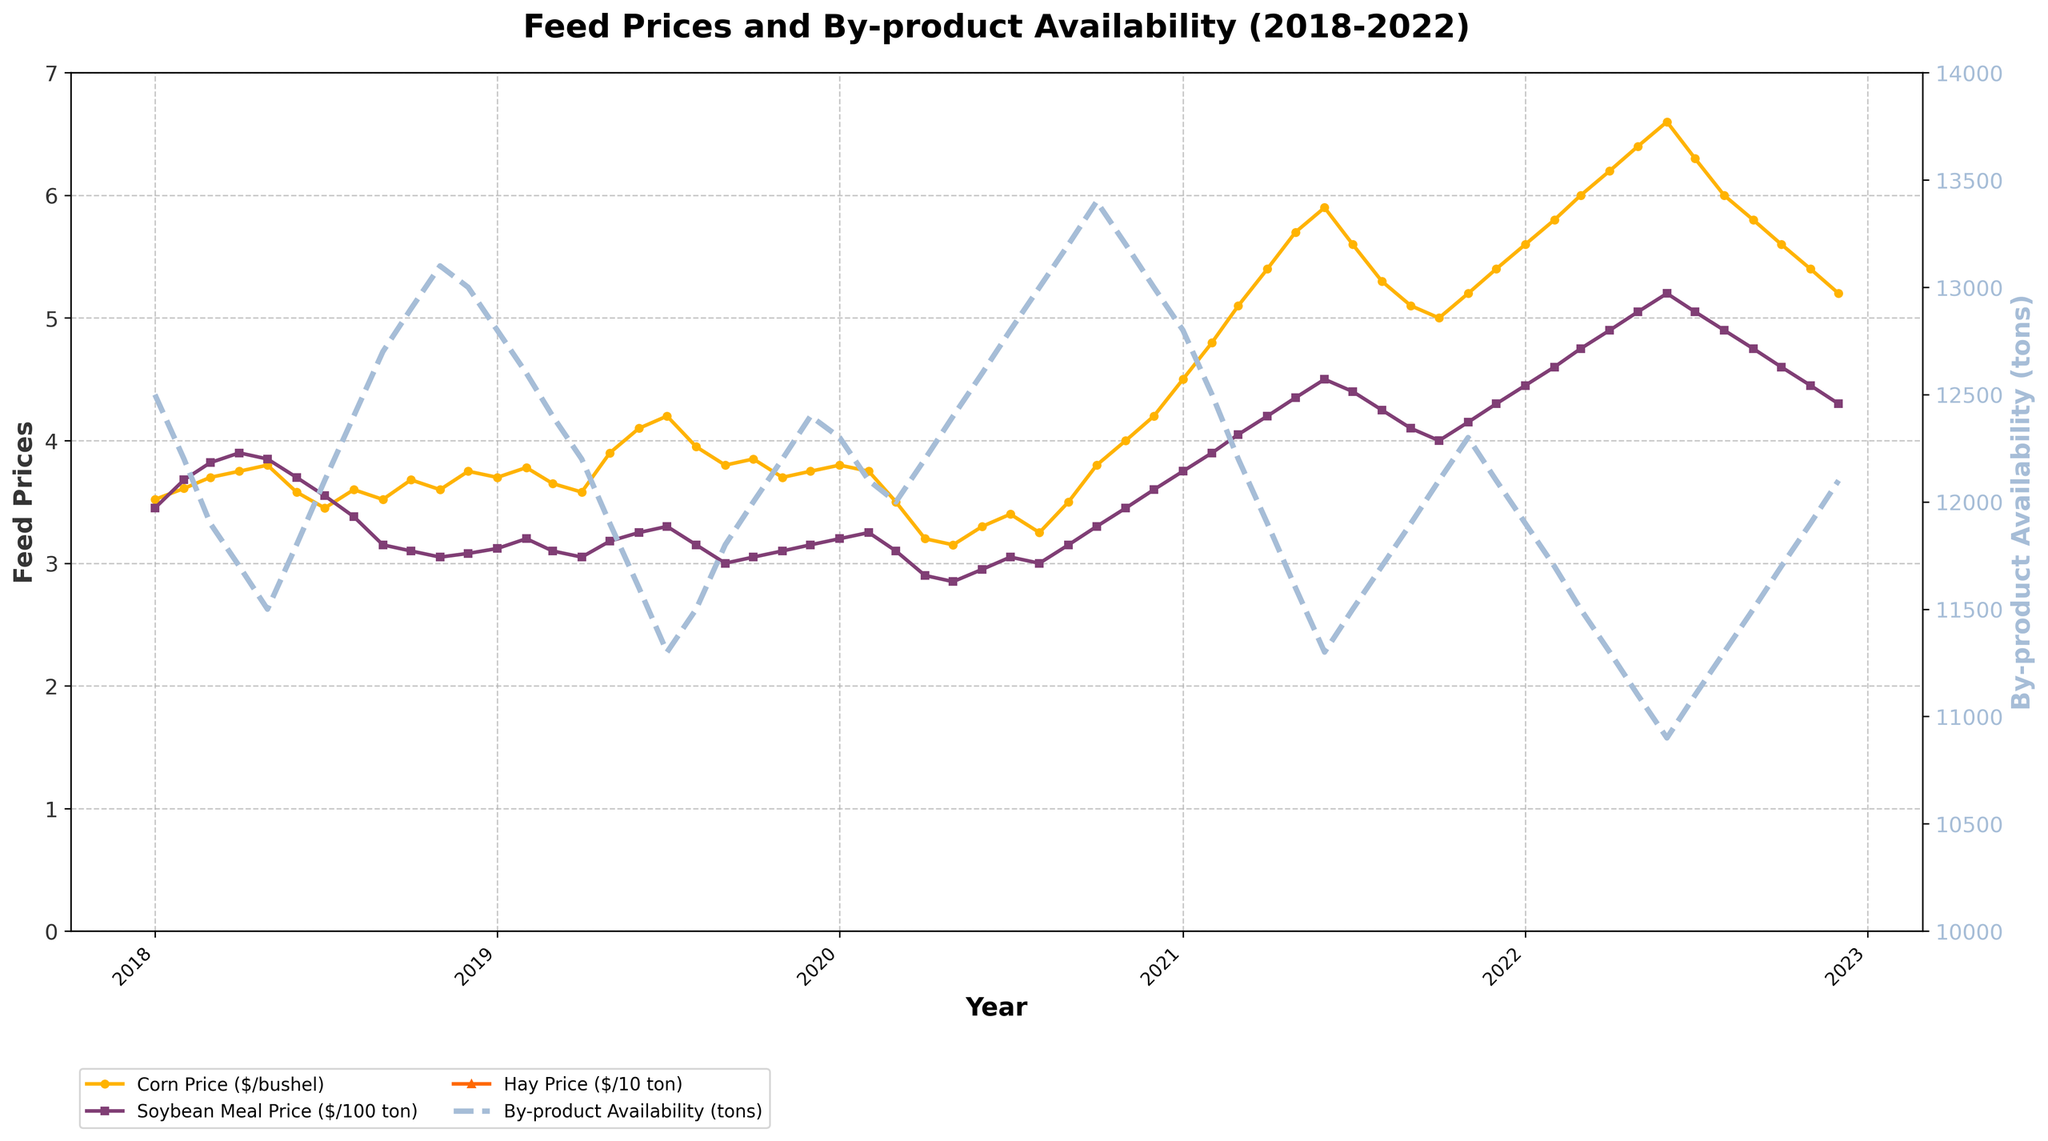What was the highest price for corn over the observed period? Look at the line for Corn Price ($/bushel) and identify the peak point. The highest value is reached in Mar 2022 at $6.00 per bushel.
Answer: $6.00 per bushel How did the availability of by-products change from Jan 2020 to Dec 2020? Find the By-product Availability line between Jan 2020 and Dec 2020. It starts at 12,300 tons in Jan 2020 and slightly dips to 13,000 tons by Dec 2020.
Answer: Decreased Which month had the highest soybean meal price, and what was the price? Observe the Soybean Meal Price ($/ton) line to find the peak point. The highest point is May 2021 at $505 per ton.
Answer: May 2021 at $505 per ton What is the average hay price in 2021? Sum the monthly hay prices for 2021 and divide by the number of months (12). (240+242+245+248+250+252+255+258+260+262+265+268)/12 = 253.08
Answer: $253.08 per ton Compare the corn price in Jan 2018 and Jan 2022. Which one is higher? Check the values of the Corn Price line in Jan 2018 and Jan 2022. Jan 2022 has a higher value at $5.60 per bushel compared to Jan 2018 at $3.52 per bushel.
Answer: Jan 2022 Which feed price fluctuates the most over the 5-year period? Visually inspect the three feed price lines for variability. Soybean Meal Price shows the most significant fluctuations.
Answer: Soybean Meal Price When did by-product availability reach a minimum, and what was that value? Look at the By-product Availability line to find the lowest point. The minimum value is reached in Jun 2020 at 10,900 tons.
Answer: Jun 2020 at 10,900 tons During which period did the corn price show a steady increase? Analyze the Corn Price line over the years for prolonged upward trends. A steady increase is seen from Apr 2020 to Jun 2021.
Answer: Apr 2020 to Jun 2021 